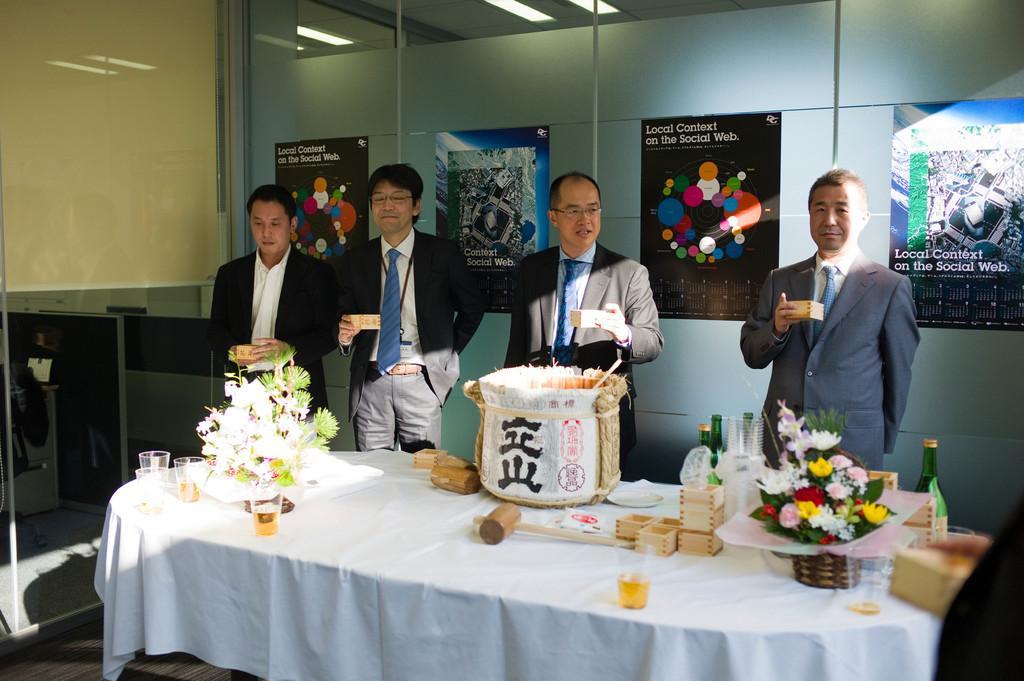Describe this image in one or two sentences. There are four men standing holding boxes in their hands in front of a table. On the table there is a bouquet, glasses, a basket and some boxes here with some bottles. There is a cloth on the table. In the background, there are some posters stuck to the glasses. 